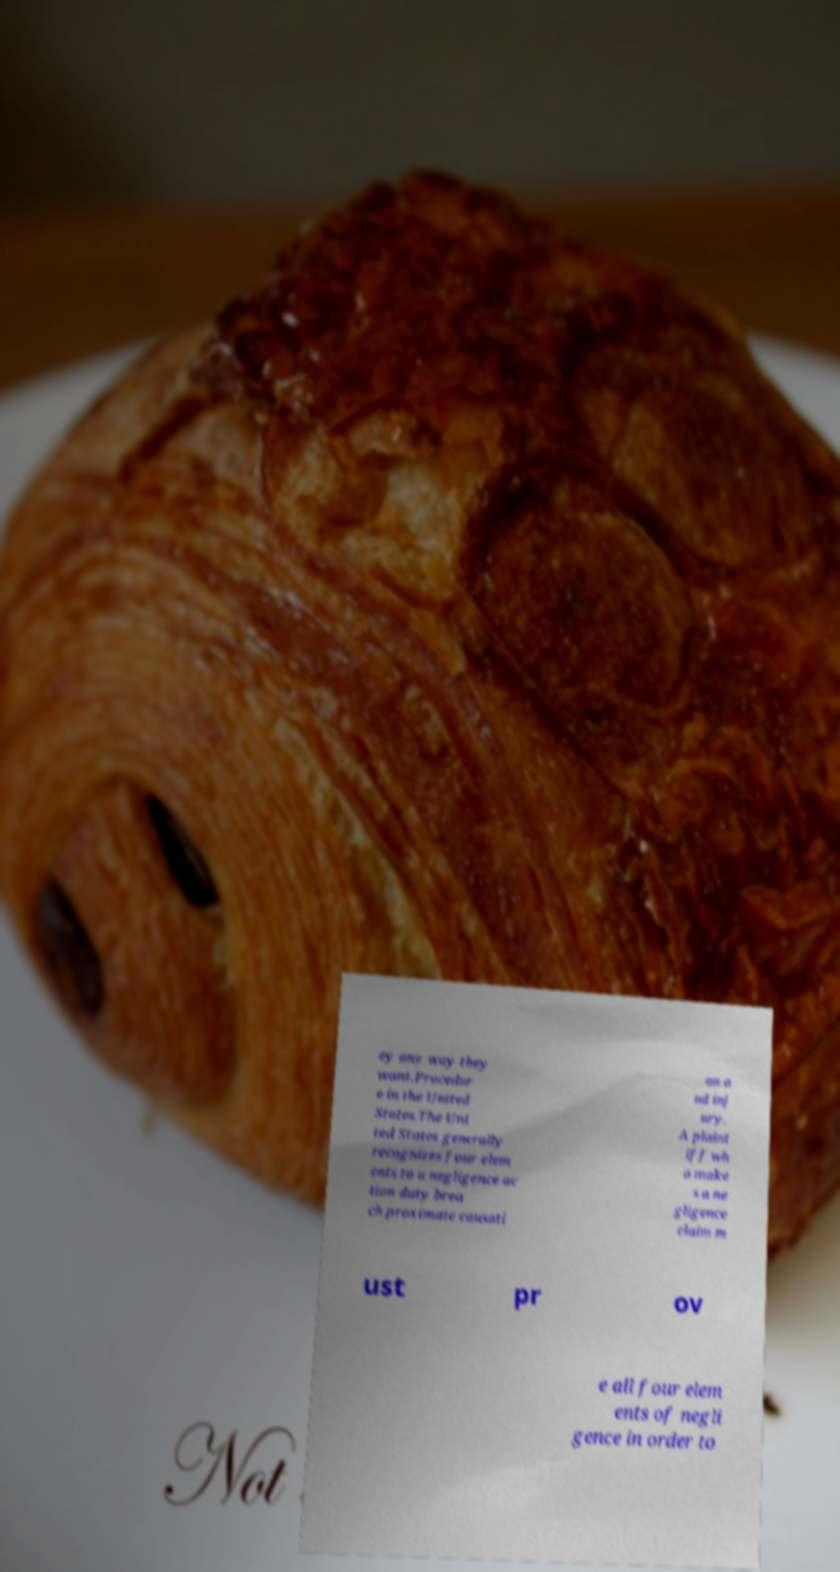Could you assist in decoding the text presented in this image and type it out clearly? ey any way they want.Procedur e in the United States.The Uni ted States generally recognizes four elem ents to a negligence ac tion duty brea ch proximate causati on a nd inj ury. A plaint iff wh o make s a ne gligence claim m ust pr ov e all four elem ents of negli gence in order to 